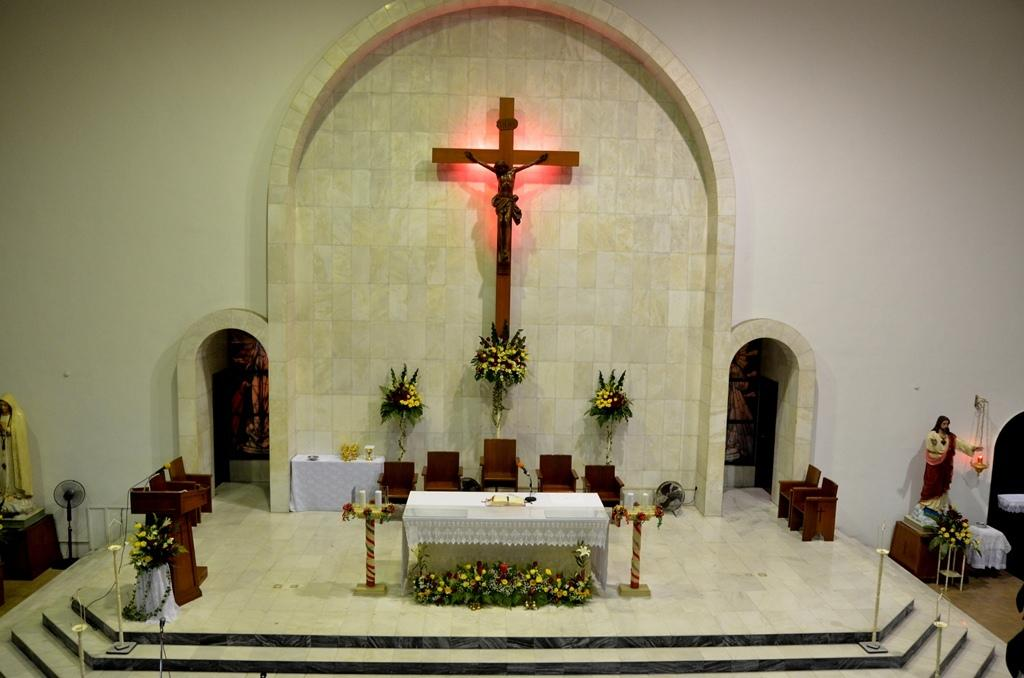What type of furniture is on the floor in the image? There are tables and chairs on the floor in the image. What religious symbol can be seen in the image? There is a cross in the image. What type of decorative objects are in the image? There are statues and flower bouquets in the image. What other objects can be seen in the image? There are other objects in the image, but their specific details are not mentioned in the provided facts. What is visible in the background of the image? There is a wall in the background of the image. Can you tell me how much the shop values the flower bouquets in the image? There is no information about a shop or the value of the flower bouquets in the image; it only shows the presence of the bouquets and other objects. 